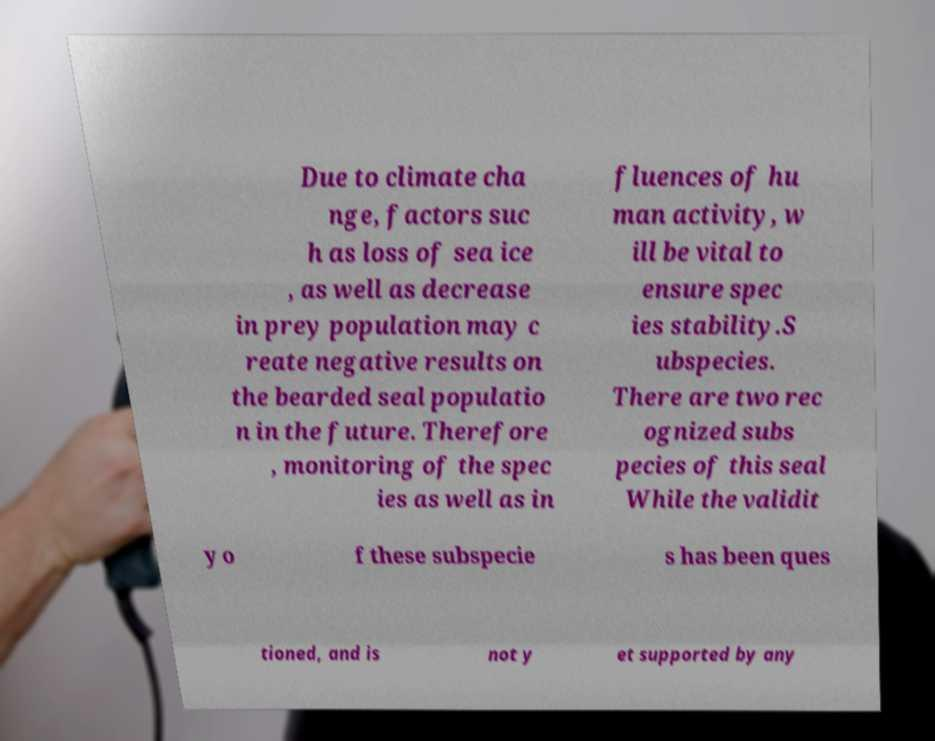For documentation purposes, I need the text within this image transcribed. Could you provide that? Due to climate cha nge, factors suc h as loss of sea ice , as well as decrease in prey population may c reate negative results on the bearded seal populatio n in the future. Therefore , monitoring of the spec ies as well as in fluences of hu man activity, w ill be vital to ensure spec ies stability.S ubspecies. There are two rec ognized subs pecies of this seal While the validit y o f these subspecie s has been ques tioned, and is not y et supported by any 